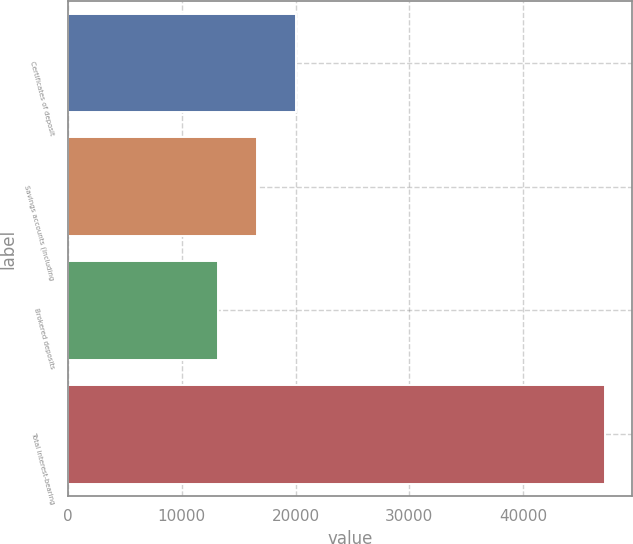<chart> <loc_0><loc_0><loc_500><loc_500><bar_chart><fcel>Certificates of deposit<fcel>Savings accounts (including<fcel>Brokered deposits<fcel>Total interest-bearing<nl><fcel>20010<fcel>16612<fcel>13214<fcel>47194<nl></chart> 